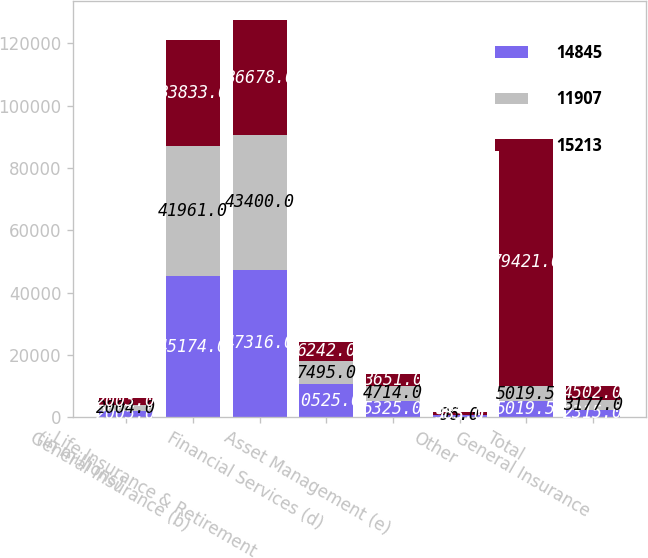Convert chart to OTSL. <chart><loc_0><loc_0><loc_500><loc_500><stacked_bar_chart><ecel><fcel>(in millions)<fcel>General Insurance (b)<fcel>Life Insurance & Retirement<fcel>Financial Services (d)<fcel>Asset Management (e)<fcel>Other<fcel>Total<fcel>General Insurance<nl><fcel>14845<fcel>2005<fcel>45174<fcel>47316<fcel>10525<fcel>5325<fcel>565<fcel>5019.5<fcel>2315<nl><fcel>11907<fcel>2004<fcel>41961<fcel>43400<fcel>7495<fcel>4714<fcel>96<fcel>5019.5<fcel>3177<nl><fcel>15213<fcel>2003<fcel>33833<fcel>36678<fcel>6242<fcel>3651<fcel>983<fcel>79421<fcel>4502<nl></chart> 